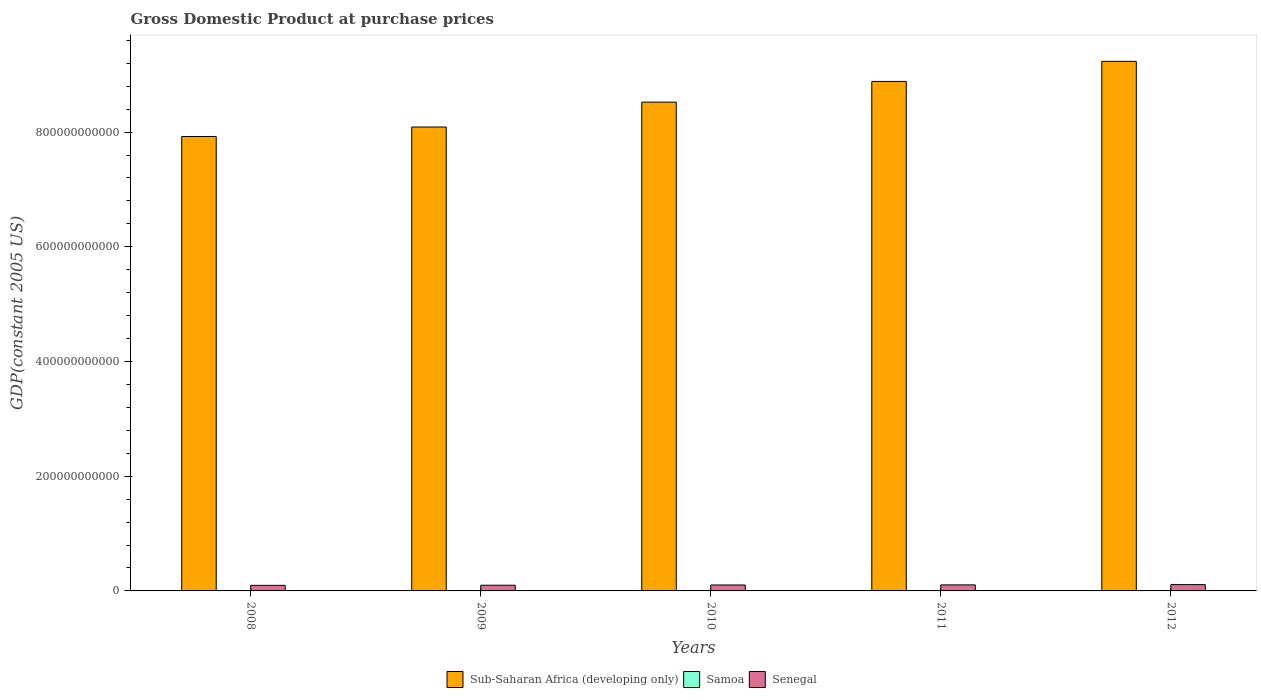How many different coloured bars are there?
Your response must be concise. 3. How many groups of bars are there?
Your answer should be compact. 5. How many bars are there on the 1st tick from the right?
Provide a short and direct response. 3. What is the label of the 2nd group of bars from the left?
Your answer should be compact. 2009. In how many cases, is the number of bars for a given year not equal to the number of legend labels?
Provide a succinct answer. 0. What is the GDP at purchase prices in Sub-Saharan Africa (developing only) in 2012?
Provide a succinct answer. 9.23e+11. Across all years, what is the maximum GDP at purchase prices in Senegal?
Make the answer very short. 1.10e+1. Across all years, what is the minimum GDP at purchase prices in Samoa?
Make the answer very short. 4.85e+08. What is the total GDP at purchase prices in Samoa in the graph?
Keep it short and to the point. 2.52e+09. What is the difference between the GDP at purchase prices in Sub-Saharan Africa (developing only) in 2008 and that in 2009?
Your response must be concise. -1.66e+1. What is the difference between the GDP at purchase prices in Senegal in 2009 and the GDP at purchase prices in Samoa in 2012?
Give a very brief answer. 9.42e+09. What is the average GDP at purchase prices in Sub-Saharan Africa (developing only) per year?
Offer a very short reply. 8.53e+11. In the year 2011, what is the difference between the GDP at purchase prices in Samoa and GDP at purchase prices in Sub-Saharan Africa (developing only)?
Your answer should be very brief. -8.88e+11. In how many years, is the GDP at purchase prices in Sub-Saharan Africa (developing only) greater than 80000000000 US$?
Provide a short and direct response. 5. What is the ratio of the GDP at purchase prices in Senegal in 2008 to that in 2009?
Give a very brief answer. 0.98. What is the difference between the highest and the second highest GDP at purchase prices in Sub-Saharan Africa (developing only)?
Keep it short and to the point. 3.50e+1. What is the difference between the highest and the lowest GDP at purchase prices in Samoa?
Your answer should be very brief. 3.26e+07. In how many years, is the GDP at purchase prices in Sub-Saharan Africa (developing only) greater than the average GDP at purchase prices in Sub-Saharan Africa (developing only) taken over all years?
Offer a very short reply. 2. What does the 3rd bar from the left in 2008 represents?
Keep it short and to the point. Senegal. What does the 3rd bar from the right in 2011 represents?
Keep it short and to the point. Sub-Saharan Africa (developing only). How many bars are there?
Provide a short and direct response. 15. What is the difference between two consecutive major ticks on the Y-axis?
Keep it short and to the point. 2.00e+11. Are the values on the major ticks of Y-axis written in scientific E-notation?
Make the answer very short. No. Does the graph contain grids?
Keep it short and to the point. No. How many legend labels are there?
Give a very brief answer. 3. How are the legend labels stacked?
Keep it short and to the point. Horizontal. What is the title of the graph?
Ensure brevity in your answer.  Gross Domestic Product at purchase prices. What is the label or title of the Y-axis?
Provide a short and direct response. GDP(constant 2005 US). What is the GDP(constant 2005 US) in Sub-Saharan Africa (developing only) in 2008?
Your answer should be very brief. 7.92e+11. What is the GDP(constant 2005 US) of Samoa in 2008?
Give a very brief answer. 5.10e+08. What is the GDP(constant 2005 US) of Senegal in 2008?
Offer a terse response. 9.71e+09. What is the GDP(constant 2005 US) of Sub-Saharan Africa (developing only) in 2009?
Offer a very short reply. 8.09e+11. What is the GDP(constant 2005 US) of Samoa in 2009?
Give a very brief answer. 4.85e+08. What is the GDP(constant 2005 US) in Senegal in 2009?
Make the answer very short. 9.94e+09. What is the GDP(constant 2005 US) in Sub-Saharan Africa (developing only) in 2010?
Offer a very short reply. 8.52e+11. What is the GDP(constant 2005 US) of Samoa in 2010?
Keep it short and to the point. 4.88e+08. What is the GDP(constant 2005 US) of Senegal in 2010?
Your answer should be compact. 1.04e+1. What is the GDP(constant 2005 US) of Sub-Saharan Africa (developing only) in 2011?
Make the answer very short. 8.88e+11. What is the GDP(constant 2005 US) in Samoa in 2011?
Give a very brief answer. 5.16e+08. What is the GDP(constant 2005 US) in Senegal in 2011?
Your answer should be very brief. 1.05e+1. What is the GDP(constant 2005 US) in Sub-Saharan Africa (developing only) in 2012?
Provide a short and direct response. 9.23e+11. What is the GDP(constant 2005 US) of Samoa in 2012?
Make the answer very short. 5.18e+08. What is the GDP(constant 2005 US) in Senegal in 2012?
Provide a succinct answer. 1.10e+1. Across all years, what is the maximum GDP(constant 2005 US) of Sub-Saharan Africa (developing only)?
Ensure brevity in your answer.  9.23e+11. Across all years, what is the maximum GDP(constant 2005 US) in Samoa?
Keep it short and to the point. 5.18e+08. Across all years, what is the maximum GDP(constant 2005 US) in Senegal?
Ensure brevity in your answer.  1.10e+1. Across all years, what is the minimum GDP(constant 2005 US) of Sub-Saharan Africa (developing only)?
Provide a short and direct response. 7.92e+11. Across all years, what is the minimum GDP(constant 2005 US) in Samoa?
Offer a terse response. 4.85e+08. Across all years, what is the minimum GDP(constant 2005 US) in Senegal?
Provide a short and direct response. 9.71e+09. What is the total GDP(constant 2005 US) in Sub-Saharan Africa (developing only) in the graph?
Make the answer very short. 4.26e+12. What is the total GDP(constant 2005 US) in Samoa in the graph?
Keep it short and to the point. 2.52e+09. What is the total GDP(constant 2005 US) in Senegal in the graph?
Provide a short and direct response. 5.15e+1. What is the difference between the GDP(constant 2005 US) of Sub-Saharan Africa (developing only) in 2008 and that in 2009?
Keep it short and to the point. -1.66e+1. What is the difference between the GDP(constant 2005 US) in Samoa in 2008 and that in 2009?
Give a very brief answer. 2.45e+07. What is the difference between the GDP(constant 2005 US) of Senegal in 2008 and that in 2009?
Provide a short and direct response. -2.35e+08. What is the difference between the GDP(constant 2005 US) in Sub-Saharan Africa (developing only) in 2008 and that in 2010?
Keep it short and to the point. -5.99e+1. What is the difference between the GDP(constant 2005 US) of Samoa in 2008 and that in 2010?
Your answer should be compact. 2.22e+07. What is the difference between the GDP(constant 2005 US) of Senegal in 2008 and that in 2010?
Provide a short and direct response. -6.51e+08. What is the difference between the GDP(constant 2005 US) of Sub-Saharan Africa (developing only) in 2008 and that in 2011?
Offer a very short reply. -9.60e+1. What is the difference between the GDP(constant 2005 US) of Samoa in 2008 and that in 2011?
Provide a succinct answer. -5.79e+06. What is the difference between the GDP(constant 2005 US) of Senegal in 2008 and that in 2011?
Keep it short and to the point. -8.33e+08. What is the difference between the GDP(constant 2005 US) of Sub-Saharan Africa (developing only) in 2008 and that in 2012?
Your response must be concise. -1.31e+11. What is the difference between the GDP(constant 2005 US) of Samoa in 2008 and that in 2012?
Offer a very short reply. -8.05e+06. What is the difference between the GDP(constant 2005 US) of Senegal in 2008 and that in 2012?
Your answer should be very brief. -1.29e+09. What is the difference between the GDP(constant 2005 US) in Sub-Saharan Africa (developing only) in 2009 and that in 2010?
Give a very brief answer. -4.34e+1. What is the difference between the GDP(constant 2005 US) of Samoa in 2009 and that in 2010?
Offer a terse response. -2.33e+06. What is the difference between the GDP(constant 2005 US) in Senegal in 2009 and that in 2010?
Make the answer very short. -4.16e+08. What is the difference between the GDP(constant 2005 US) of Sub-Saharan Africa (developing only) in 2009 and that in 2011?
Keep it short and to the point. -7.95e+1. What is the difference between the GDP(constant 2005 US) in Samoa in 2009 and that in 2011?
Your answer should be compact. -3.03e+07. What is the difference between the GDP(constant 2005 US) in Senegal in 2009 and that in 2011?
Offer a terse response. -5.98e+08. What is the difference between the GDP(constant 2005 US) of Sub-Saharan Africa (developing only) in 2009 and that in 2012?
Make the answer very short. -1.14e+11. What is the difference between the GDP(constant 2005 US) of Samoa in 2009 and that in 2012?
Your answer should be compact. -3.26e+07. What is the difference between the GDP(constant 2005 US) of Senegal in 2009 and that in 2012?
Offer a terse response. -1.06e+09. What is the difference between the GDP(constant 2005 US) of Sub-Saharan Africa (developing only) in 2010 and that in 2011?
Make the answer very short. -3.61e+1. What is the difference between the GDP(constant 2005 US) of Samoa in 2010 and that in 2011?
Your response must be concise. -2.80e+07. What is the difference between the GDP(constant 2005 US) of Senegal in 2010 and that in 2011?
Your answer should be compact. -1.82e+08. What is the difference between the GDP(constant 2005 US) of Sub-Saharan Africa (developing only) in 2010 and that in 2012?
Your response must be concise. -7.11e+1. What is the difference between the GDP(constant 2005 US) of Samoa in 2010 and that in 2012?
Provide a succinct answer. -3.02e+07. What is the difference between the GDP(constant 2005 US) of Senegal in 2010 and that in 2012?
Ensure brevity in your answer.  -6.42e+08. What is the difference between the GDP(constant 2005 US) of Sub-Saharan Africa (developing only) in 2011 and that in 2012?
Your response must be concise. -3.50e+1. What is the difference between the GDP(constant 2005 US) in Samoa in 2011 and that in 2012?
Offer a very short reply. -2.27e+06. What is the difference between the GDP(constant 2005 US) in Senegal in 2011 and that in 2012?
Make the answer very short. -4.60e+08. What is the difference between the GDP(constant 2005 US) of Sub-Saharan Africa (developing only) in 2008 and the GDP(constant 2005 US) of Samoa in 2009?
Your answer should be compact. 7.92e+11. What is the difference between the GDP(constant 2005 US) in Sub-Saharan Africa (developing only) in 2008 and the GDP(constant 2005 US) in Senegal in 2009?
Your answer should be compact. 7.82e+11. What is the difference between the GDP(constant 2005 US) in Samoa in 2008 and the GDP(constant 2005 US) in Senegal in 2009?
Make the answer very short. -9.43e+09. What is the difference between the GDP(constant 2005 US) of Sub-Saharan Africa (developing only) in 2008 and the GDP(constant 2005 US) of Samoa in 2010?
Ensure brevity in your answer.  7.92e+11. What is the difference between the GDP(constant 2005 US) in Sub-Saharan Africa (developing only) in 2008 and the GDP(constant 2005 US) in Senegal in 2010?
Ensure brevity in your answer.  7.82e+11. What is the difference between the GDP(constant 2005 US) in Samoa in 2008 and the GDP(constant 2005 US) in Senegal in 2010?
Ensure brevity in your answer.  -9.85e+09. What is the difference between the GDP(constant 2005 US) in Sub-Saharan Africa (developing only) in 2008 and the GDP(constant 2005 US) in Samoa in 2011?
Your answer should be very brief. 7.92e+11. What is the difference between the GDP(constant 2005 US) of Sub-Saharan Africa (developing only) in 2008 and the GDP(constant 2005 US) of Senegal in 2011?
Your response must be concise. 7.82e+11. What is the difference between the GDP(constant 2005 US) in Samoa in 2008 and the GDP(constant 2005 US) in Senegal in 2011?
Your answer should be compact. -1.00e+1. What is the difference between the GDP(constant 2005 US) in Sub-Saharan Africa (developing only) in 2008 and the GDP(constant 2005 US) in Samoa in 2012?
Provide a short and direct response. 7.92e+11. What is the difference between the GDP(constant 2005 US) in Sub-Saharan Africa (developing only) in 2008 and the GDP(constant 2005 US) in Senegal in 2012?
Provide a short and direct response. 7.81e+11. What is the difference between the GDP(constant 2005 US) of Samoa in 2008 and the GDP(constant 2005 US) of Senegal in 2012?
Make the answer very short. -1.05e+1. What is the difference between the GDP(constant 2005 US) in Sub-Saharan Africa (developing only) in 2009 and the GDP(constant 2005 US) in Samoa in 2010?
Provide a short and direct response. 8.08e+11. What is the difference between the GDP(constant 2005 US) of Sub-Saharan Africa (developing only) in 2009 and the GDP(constant 2005 US) of Senegal in 2010?
Your answer should be compact. 7.98e+11. What is the difference between the GDP(constant 2005 US) in Samoa in 2009 and the GDP(constant 2005 US) in Senegal in 2010?
Give a very brief answer. -9.87e+09. What is the difference between the GDP(constant 2005 US) in Sub-Saharan Africa (developing only) in 2009 and the GDP(constant 2005 US) in Samoa in 2011?
Make the answer very short. 8.08e+11. What is the difference between the GDP(constant 2005 US) of Sub-Saharan Africa (developing only) in 2009 and the GDP(constant 2005 US) of Senegal in 2011?
Give a very brief answer. 7.98e+11. What is the difference between the GDP(constant 2005 US) of Samoa in 2009 and the GDP(constant 2005 US) of Senegal in 2011?
Your answer should be very brief. -1.01e+1. What is the difference between the GDP(constant 2005 US) of Sub-Saharan Africa (developing only) in 2009 and the GDP(constant 2005 US) of Samoa in 2012?
Your answer should be compact. 8.08e+11. What is the difference between the GDP(constant 2005 US) of Sub-Saharan Africa (developing only) in 2009 and the GDP(constant 2005 US) of Senegal in 2012?
Your answer should be compact. 7.98e+11. What is the difference between the GDP(constant 2005 US) of Samoa in 2009 and the GDP(constant 2005 US) of Senegal in 2012?
Give a very brief answer. -1.05e+1. What is the difference between the GDP(constant 2005 US) in Sub-Saharan Africa (developing only) in 2010 and the GDP(constant 2005 US) in Samoa in 2011?
Offer a very short reply. 8.52e+11. What is the difference between the GDP(constant 2005 US) of Sub-Saharan Africa (developing only) in 2010 and the GDP(constant 2005 US) of Senegal in 2011?
Your response must be concise. 8.42e+11. What is the difference between the GDP(constant 2005 US) of Samoa in 2010 and the GDP(constant 2005 US) of Senegal in 2011?
Offer a terse response. -1.01e+1. What is the difference between the GDP(constant 2005 US) of Sub-Saharan Africa (developing only) in 2010 and the GDP(constant 2005 US) of Samoa in 2012?
Keep it short and to the point. 8.52e+11. What is the difference between the GDP(constant 2005 US) in Sub-Saharan Africa (developing only) in 2010 and the GDP(constant 2005 US) in Senegal in 2012?
Give a very brief answer. 8.41e+11. What is the difference between the GDP(constant 2005 US) of Samoa in 2010 and the GDP(constant 2005 US) of Senegal in 2012?
Your answer should be compact. -1.05e+1. What is the difference between the GDP(constant 2005 US) of Sub-Saharan Africa (developing only) in 2011 and the GDP(constant 2005 US) of Samoa in 2012?
Make the answer very short. 8.88e+11. What is the difference between the GDP(constant 2005 US) of Sub-Saharan Africa (developing only) in 2011 and the GDP(constant 2005 US) of Senegal in 2012?
Your answer should be compact. 8.77e+11. What is the difference between the GDP(constant 2005 US) in Samoa in 2011 and the GDP(constant 2005 US) in Senegal in 2012?
Your answer should be compact. -1.05e+1. What is the average GDP(constant 2005 US) of Sub-Saharan Africa (developing only) per year?
Keep it short and to the point. 8.53e+11. What is the average GDP(constant 2005 US) of Samoa per year?
Give a very brief answer. 5.03e+08. What is the average GDP(constant 2005 US) of Senegal per year?
Offer a very short reply. 1.03e+1. In the year 2008, what is the difference between the GDP(constant 2005 US) of Sub-Saharan Africa (developing only) and GDP(constant 2005 US) of Samoa?
Give a very brief answer. 7.92e+11. In the year 2008, what is the difference between the GDP(constant 2005 US) in Sub-Saharan Africa (developing only) and GDP(constant 2005 US) in Senegal?
Give a very brief answer. 7.83e+11. In the year 2008, what is the difference between the GDP(constant 2005 US) of Samoa and GDP(constant 2005 US) of Senegal?
Your answer should be compact. -9.20e+09. In the year 2009, what is the difference between the GDP(constant 2005 US) in Sub-Saharan Africa (developing only) and GDP(constant 2005 US) in Samoa?
Keep it short and to the point. 8.08e+11. In the year 2009, what is the difference between the GDP(constant 2005 US) in Sub-Saharan Africa (developing only) and GDP(constant 2005 US) in Senegal?
Keep it short and to the point. 7.99e+11. In the year 2009, what is the difference between the GDP(constant 2005 US) of Samoa and GDP(constant 2005 US) of Senegal?
Give a very brief answer. -9.46e+09. In the year 2010, what is the difference between the GDP(constant 2005 US) in Sub-Saharan Africa (developing only) and GDP(constant 2005 US) in Samoa?
Keep it short and to the point. 8.52e+11. In the year 2010, what is the difference between the GDP(constant 2005 US) in Sub-Saharan Africa (developing only) and GDP(constant 2005 US) in Senegal?
Make the answer very short. 8.42e+11. In the year 2010, what is the difference between the GDP(constant 2005 US) in Samoa and GDP(constant 2005 US) in Senegal?
Offer a very short reply. -9.87e+09. In the year 2011, what is the difference between the GDP(constant 2005 US) in Sub-Saharan Africa (developing only) and GDP(constant 2005 US) in Samoa?
Provide a succinct answer. 8.88e+11. In the year 2011, what is the difference between the GDP(constant 2005 US) in Sub-Saharan Africa (developing only) and GDP(constant 2005 US) in Senegal?
Provide a succinct answer. 8.78e+11. In the year 2011, what is the difference between the GDP(constant 2005 US) in Samoa and GDP(constant 2005 US) in Senegal?
Give a very brief answer. -1.00e+1. In the year 2012, what is the difference between the GDP(constant 2005 US) in Sub-Saharan Africa (developing only) and GDP(constant 2005 US) in Samoa?
Your response must be concise. 9.23e+11. In the year 2012, what is the difference between the GDP(constant 2005 US) in Sub-Saharan Africa (developing only) and GDP(constant 2005 US) in Senegal?
Your response must be concise. 9.12e+11. In the year 2012, what is the difference between the GDP(constant 2005 US) of Samoa and GDP(constant 2005 US) of Senegal?
Give a very brief answer. -1.05e+1. What is the ratio of the GDP(constant 2005 US) of Sub-Saharan Africa (developing only) in 2008 to that in 2009?
Keep it short and to the point. 0.98. What is the ratio of the GDP(constant 2005 US) of Samoa in 2008 to that in 2009?
Give a very brief answer. 1.05. What is the ratio of the GDP(constant 2005 US) in Senegal in 2008 to that in 2009?
Make the answer very short. 0.98. What is the ratio of the GDP(constant 2005 US) of Sub-Saharan Africa (developing only) in 2008 to that in 2010?
Your response must be concise. 0.93. What is the ratio of the GDP(constant 2005 US) in Samoa in 2008 to that in 2010?
Your answer should be compact. 1.05. What is the ratio of the GDP(constant 2005 US) of Senegal in 2008 to that in 2010?
Provide a succinct answer. 0.94. What is the ratio of the GDP(constant 2005 US) in Sub-Saharan Africa (developing only) in 2008 to that in 2011?
Your response must be concise. 0.89. What is the ratio of the GDP(constant 2005 US) of Samoa in 2008 to that in 2011?
Ensure brevity in your answer.  0.99. What is the ratio of the GDP(constant 2005 US) in Senegal in 2008 to that in 2011?
Give a very brief answer. 0.92. What is the ratio of the GDP(constant 2005 US) in Sub-Saharan Africa (developing only) in 2008 to that in 2012?
Keep it short and to the point. 0.86. What is the ratio of the GDP(constant 2005 US) in Samoa in 2008 to that in 2012?
Offer a terse response. 0.98. What is the ratio of the GDP(constant 2005 US) in Senegal in 2008 to that in 2012?
Offer a very short reply. 0.88. What is the ratio of the GDP(constant 2005 US) of Sub-Saharan Africa (developing only) in 2009 to that in 2010?
Ensure brevity in your answer.  0.95. What is the ratio of the GDP(constant 2005 US) of Samoa in 2009 to that in 2010?
Provide a short and direct response. 1. What is the ratio of the GDP(constant 2005 US) of Senegal in 2009 to that in 2010?
Your answer should be compact. 0.96. What is the ratio of the GDP(constant 2005 US) in Sub-Saharan Africa (developing only) in 2009 to that in 2011?
Offer a terse response. 0.91. What is the ratio of the GDP(constant 2005 US) of Senegal in 2009 to that in 2011?
Provide a short and direct response. 0.94. What is the ratio of the GDP(constant 2005 US) in Sub-Saharan Africa (developing only) in 2009 to that in 2012?
Give a very brief answer. 0.88. What is the ratio of the GDP(constant 2005 US) of Samoa in 2009 to that in 2012?
Make the answer very short. 0.94. What is the ratio of the GDP(constant 2005 US) in Senegal in 2009 to that in 2012?
Your answer should be very brief. 0.9. What is the ratio of the GDP(constant 2005 US) in Sub-Saharan Africa (developing only) in 2010 to that in 2011?
Provide a succinct answer. 0.96. What is the ratio of the GDP(constant 2005 US) in Samoa in 2010 to that in 2011?
Keep it short and to the point. 0.95. What is the ratio of the GDP(constant 2005 US) in Senegal in 2010 to that in 2011?
Make the answer very short. 0.98. What is the ratio of the GDP(constant 2005 US) of Sub-Saharan Africa (developing only) in 2010 to that in 2012?
Give a very brief answer. 0.92. What is the ratio of the GDP(constant 2005 US) in Samoa in 2010 to that in 2012?
Offer a terse response. 0.94. What is the ratio of the GDP(constant 2005 US) of Senegal in 2010 to that in 2012?
Provide a succinct answer. 0.94. What is the ratio of the GDP(constant 2005 US) in Sub-Saharan Africa (developing only) in 2011 to that in 2012?
Give a very brief answer. 0.96. What is the ratio of the GDP(constant 2005 US) in Samoa in 2011 to that in 2012?
Your answer should be very brief. 1. What is the ratio of the GDP(constant 2005 US) of Senegal in 2011 to that in 2012?
Provide a succinct answer. 0.96. What is the difference between the highest and the second highest GDP(constant 2005 US) of Sub-Saharan Africa (developing only)?
Offer a terse response. 3.50e+1. What is the difference between the highest and the second highest GDP(constant 2005 US) of Samoa?
Provide a short and direct response. 2.27e+06. What is the difference between the highest and the second highest GDP(constant 2005 US) in Senegal?
Offer a very short reply. 4.60e+08. What is the difference between the highest and the lowest GDP(constant 2005 US) of Sub-Saharan Africa (developing only)?
Keep it short and to the point. 1.31e+11. What is the difference between the highest and the lowest GDP(constant 2005 US) of Samoa?
Provide a succinct answer. 3.26e+07. What is the difference between the highest and the lowest GDP(constant 2005 US) in Senegal?
Your answer should be compact. 1.29e+09. 